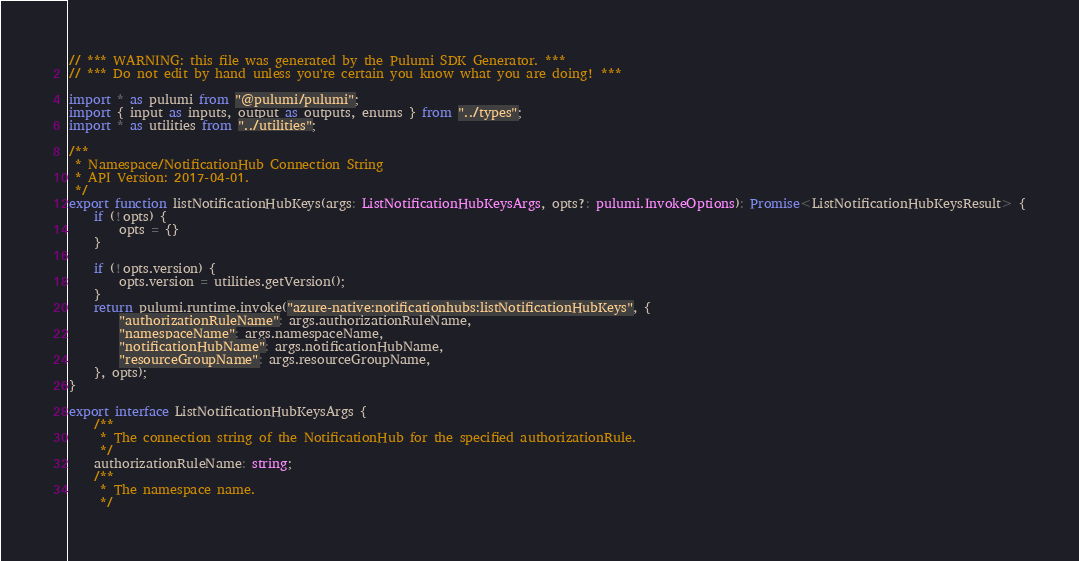<code> <loc_0><loc_0><loc_500><loc_500><_TypeScript_>// *** WARNING: this file was generated by the Pulumi SDK Generator. ***
// *** Do not edit by hand unless you're certain you know what you are doing! ***

import * as pulumi from "@pulumi/pulumi";
import { input as inputs, output as outputs, enums } from "../types";
import * as utilities from "../utilities";

/**
 * Namespace/NotificationHub Connection String
 * API Version: 2017-04-01.
 */
export function listNotificationHubKeys(args: ListNotificationHubKeysArgs, opts?: pulumi.InvokeOptions): Promise<ListNotificationHubKeysResult> {
    if (!opts) {
        opts = {}
    }

    if (!opts.version) {
        opts.version = utilities.getVersion();
    }
    return pulumi.runtime.invoke("azure-native:notificationhubs:listNotificationHubKeys", {
        "authorizationRuleName": args.authorizationRuleName,
        "namespaceName": args.namespaceName,
        "notificationHubName": args.notificationHubName,
        "resourceGroupName": args.resourceGroupName,
    }, opts);
}

export interface ListNotificationHubKeysArgs {
    /**
     * The connection string of the NotificationHub for the specified authorizationRule.
     */
    authorizationRuleName: string;
    /**
     * The namespace name.
     */</code> 